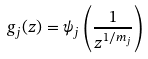Convert formula to latex. <formula><loc_0><loc_0><loc_500><loc_500>g _ { j } ( z ) = \psi _ { j } \left ( \frac { 1 } { z ^ { 1 / m _ { j } } } \right )</formula> 